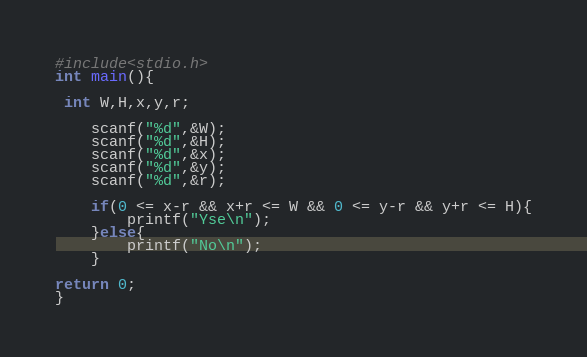<code> <loc_0><loc_0><loc_500><loc_500><_C_>#include<stdio.h>
int main(){

 int W,H,x,y,r;

	scanf("%d",&W);
	scanf("%d",&H);
	scanf("%d",&x);
	scanf("%d",&y);
	scanf("%d",&r);

	if(0 <= x-r && x+r <= W && 0 <= y-r && y+r <= H){
		printf("Yse\n");
	}else{
		printf("No\n");
	}

return 0;
}</code> 